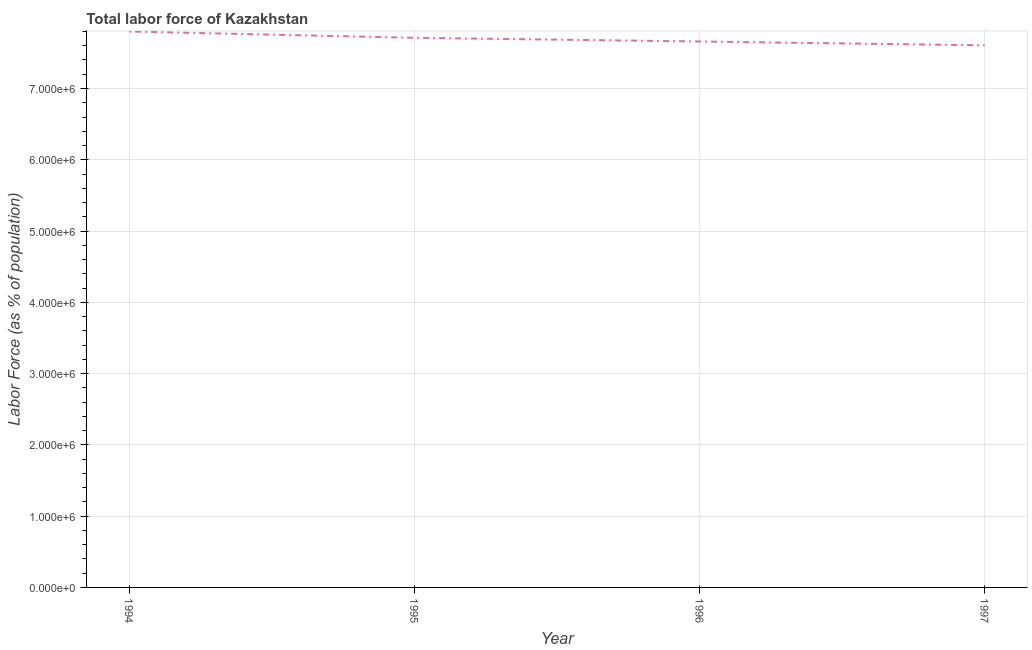What is the total labor force in 1996?
Make the answer very short. 7.66e+06. Across all years, what is the maximum total labor force?
Your answer should be very brief. 7.80e+06. Across all years, what is the minimum total labor force?
Your answer should be very brief. 7.61e+06. In which year was the total labor force maximum?
Your response must be concise. 1994. What is the sum of the total labor force?
Your response must be concise. 3.08e+07. What is the difference between the total labor force in 1994 and 1995?
Offer a terse response. 8.81e+04. What is the average total labor force per year?
Ensure brevity in your answer.  7.69e+06. What is the median total labor force?
Provide a short and direct response. 7.69e+06. In how many years, is the total labor force greater than 400000 %?
Your answer should be very brief. 4. What is the ratio of the total labor force in 1994 to that in 1996?
Provide a short and direct response. 1.02. Is the total labor force in 1994 less than that in 1995?
Your answer should be compact. No. Is the difference between the total labor force in 1994 and 1997 greater than the difference between any two years?
Your answer should be very brief. Yes. What is the difference between the highest and the second highest total labor force?
Ensure brevity in your answer.  8.81e+04. What is the difference between the highest and the lowest total labor force?
Give a very brief answer. 1.94e+05. How many years are there in the graph?
Ensure brevity in your answer.  4. What is the difference between two consecutive major ticks on the Y-axis?
Your answer should be compact. 1.00e+06. Are the values on the major ticks of Y-axis written in scientific E-notation?
Provide a succinct answer. Yes. Does the graph contain grids?
Keep it short and to the point. Yes. What is the title of the graph?
Make the answer very short. Total labor force of Kazakhstan. What is the label or title of the Y-axis?
Your answer should be compact. Labor Force (as % of population). What is the Labor Force (as % of population) in 1994?
Your response must be concise. 7.80e+06. What is the Labor Force (as % of population) of 1995?
Ensure brevity in your answer.  7.71e+06. What is the Labor Force (as % of population) in 1996?
Make the answer very short. 7.66e+06. What is the Labor Force (as % of population) in 1997?
Offer a very short reply. 7.61e+06. What is the difference between the Labor Force (as % of population) in 1994 and 1995?
Your answer should be compact. 8.81e+04. What is the difference between the Labor Force (as % of population) in 1994 and 1996?
Offer a terse response. 1.40e+05. What is the difference between the Labor Force (as % of population) in 1994 and 1997?
Keep it short and to the point. 1.94e+05. What is the difference between the Labor Force (as % of population) in 1995 and 1996?
Provide a short and direct response. 5.19e+04. What is the difference between the Labor Force (as % of population) in 1995 and 1997?
Your response must be concise. 1.05e+05. What is the difference between the Labor Force (as % of population) in 1996 and 1997?
Provide a short and direct response. 5.36e+04. What is the ratio of the Labor Force (as % of population) in 1994 to that in 1996?
Ensure brevity in your answer.  1.02. What is the ratio of the Labor Force (as % of population) in 1995 to that in 1997?
Your response must be concise. 1.01. 